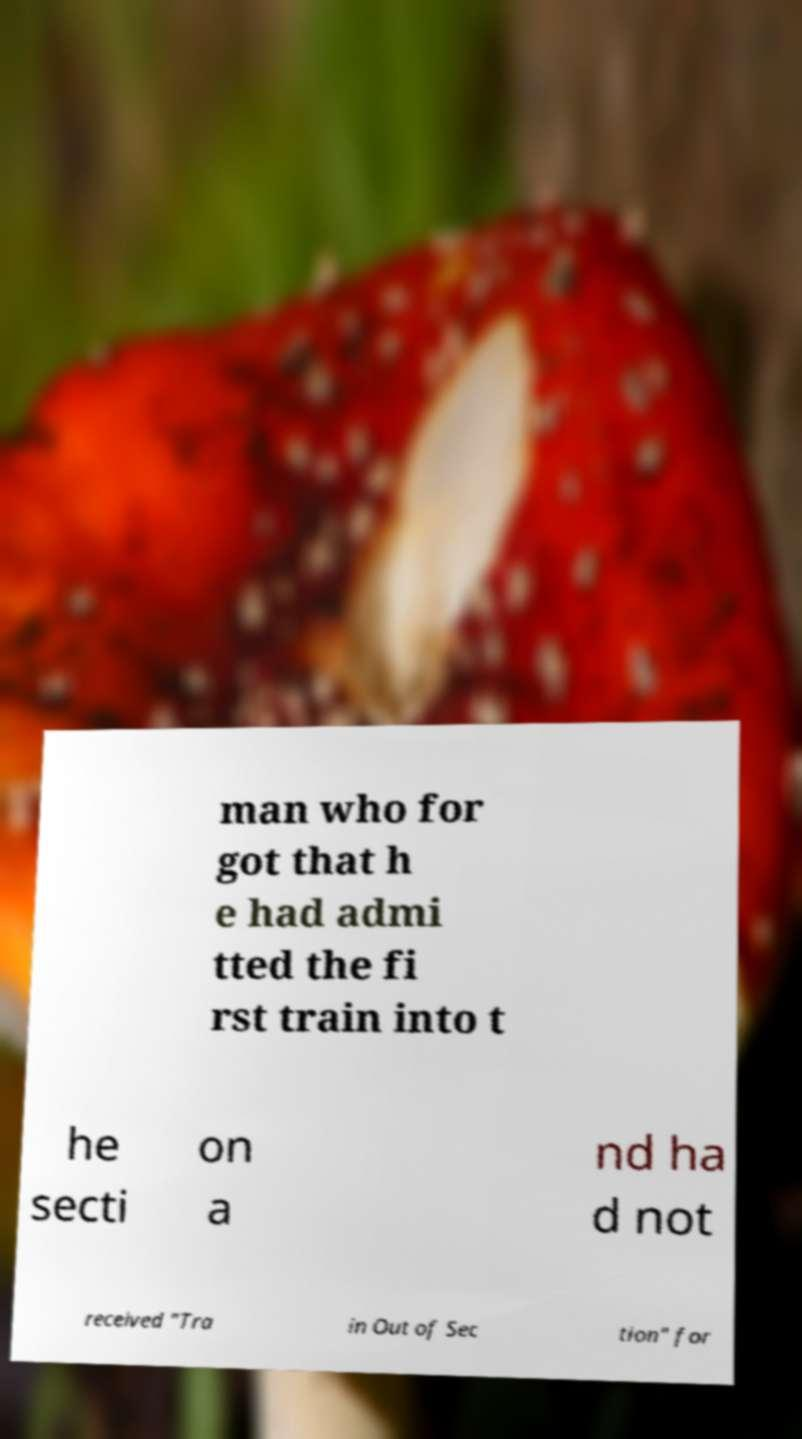Please read and relay the text visible in this image. What does it say? man who for got that h e had admi tted the fi rst train into t he secti on a nd ha d not received "Tra in Out of Sec tion" for 